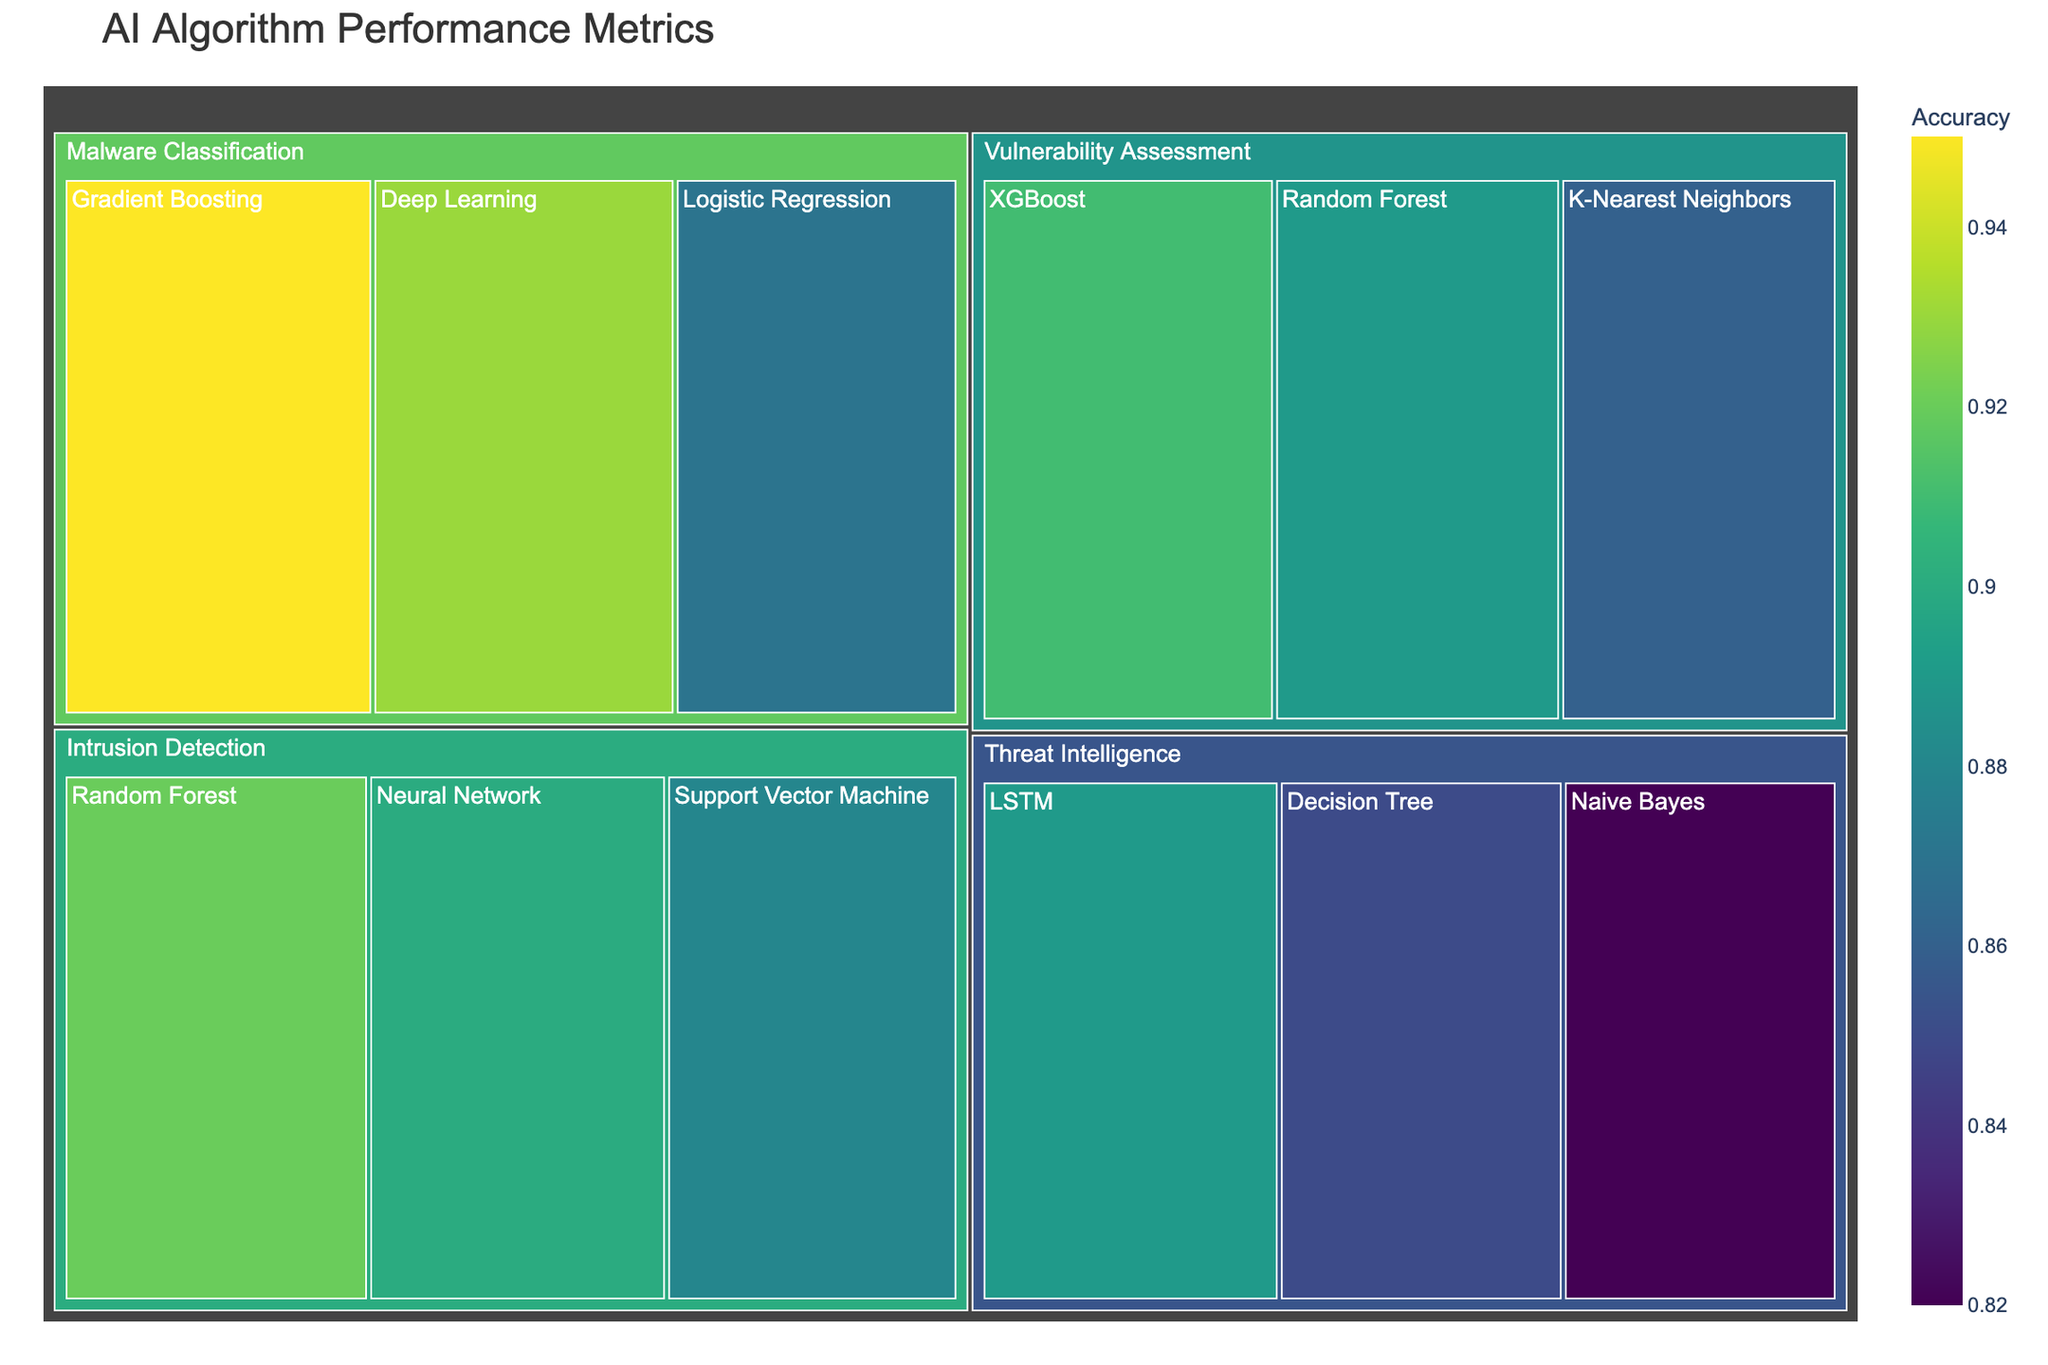What is the title of the treemap? The title is displayed at the top of the figure and gives a description of the visual representation. The title of this treemap is clearly displayed.
Answer: AI Algorithm Performance Metrics Which category has the highest accuracy model? To find this, I examine each category and compare the maximum accuracy values of the models under each category. Malware Classification has models with the highest accuracy rates, particularly the Gradient Boosting model at 0.95.
Answer: Malware Classification What is the range of accuracy rates within the Intrusion Detection category? I look at the accuracy rates of all models in the Intrusion Detection category: Random Forest (0.92), Support Vector Machine (0.88), and Neural Network (0.90). The range can be calculated as the difference between the highest and lowest values. So, the range is 0.92 - 0.88 = 0.04.
Answer: 0.04 Which model in the Threat Intelligence category has the lowest accuracy? I need to compare the accuracy rates of the models within the Threat Intelligence category. The models are LSTM (0.89), Naive Bayes (0.82), and Decision Tree (0.85). The Naive Bayes model has the lowest accuracy.
Answer: Naive Bayes Compare the accuracy of the best model in Intrusion Detection with the best model in Vulnerability Assessment. Which one is higher? The highest accuracy in Intrusion Detection is from Random Forest at 0.92. The highest accuracy in Vulnerability Assessment is XGBoost at 0.91. By comparing 0.92 and 0.91, Random Forest in Intrusion Detection is higher.
Answer: Random Forest in Intrusion Detection What is the overall average accuracy of models in Malware Classification? To find the average, sum the accuracy values of malware classification models and divide by the number of models. (0.95 + 0.93 + 0.87) / 3 = 2.75 / 3 = 0.9167.
Answer: 0.9167 How does the accuracy of the Decision Tree model in Threat Intelligence compare to the Random Forest model in Vulnerability Assessment? The accuracy of Decision Tree in Threat Intelligence is 0.85, while Random Forest in Vulnerability Assessment has an accuracy of 0.89. Thus, the Random Forest model has a higher accuracy.
Answer: Random Forest in Vulnerability Assessment Which category contains the model with the single highest accuracy rate and what is that rate? To find the category containing the highest accuracy model, I need to look at all the models' accuracy rates. Gradient Boosting in Malware Classification has the highest accuracy at 0.95.
Answer: Malware Classification, 0.95 